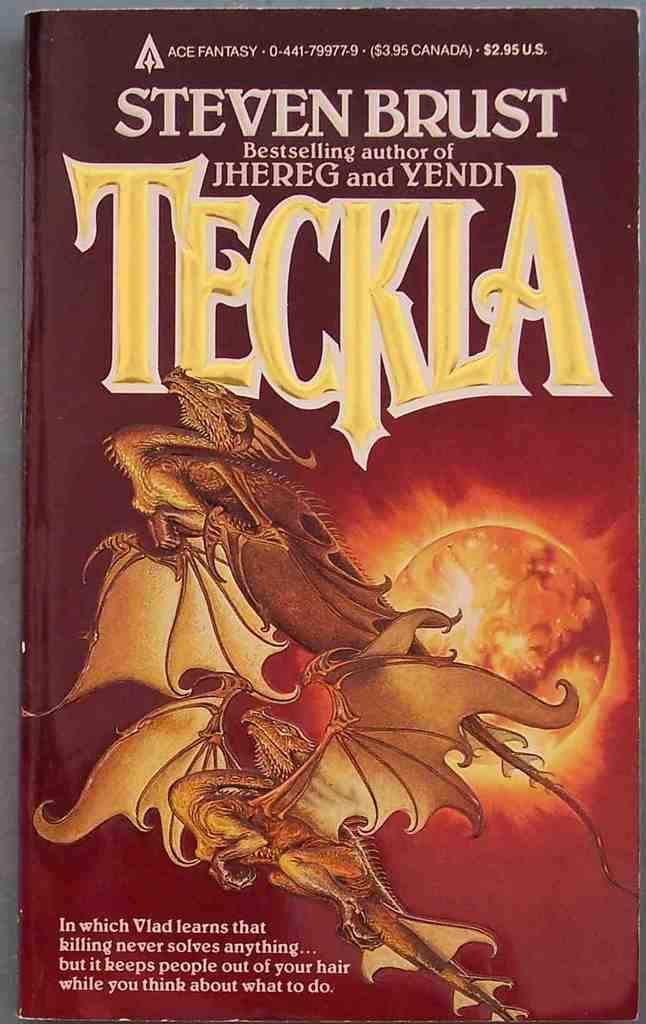<image>
Provide a brief description of the given image. A book that is about fantasy titled Teckla. 